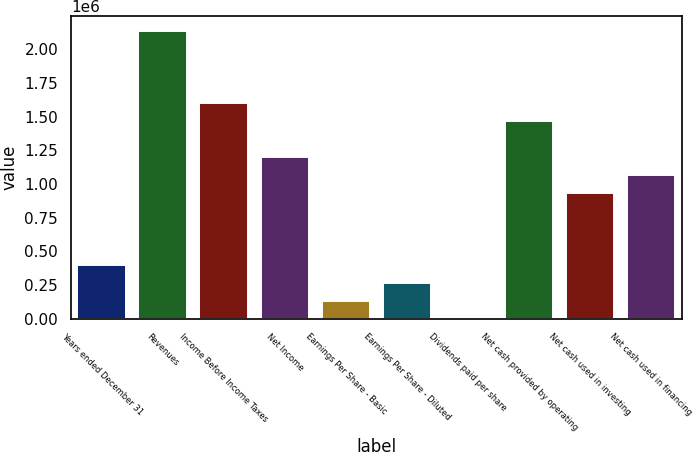<chart> <loc_0><loc_0><loc_500><loc_500><bar_chart><fcel>Years ended December 31<fcel>Revenues<fcel>Income Before Income Taxes<fcel>Net Income<fcel>Earnings Per Share - Basic<fcel>Earnings Per Share - Diluted<fcel>Dividends paid per share<fcel>Net cash provided by operating<fcel>Net cash used in investing<fcel>Net cash used in financing<nl><fcel>401213<fcel>2.1398e+06<fcel>1.60485e+06<fcel>1.20364e+06<fcel>133738<fcel>267475<fcel>0.45<fcel>1.47111e+06<fcel>936162<fcel>1.0699e+06<nl></chart> 